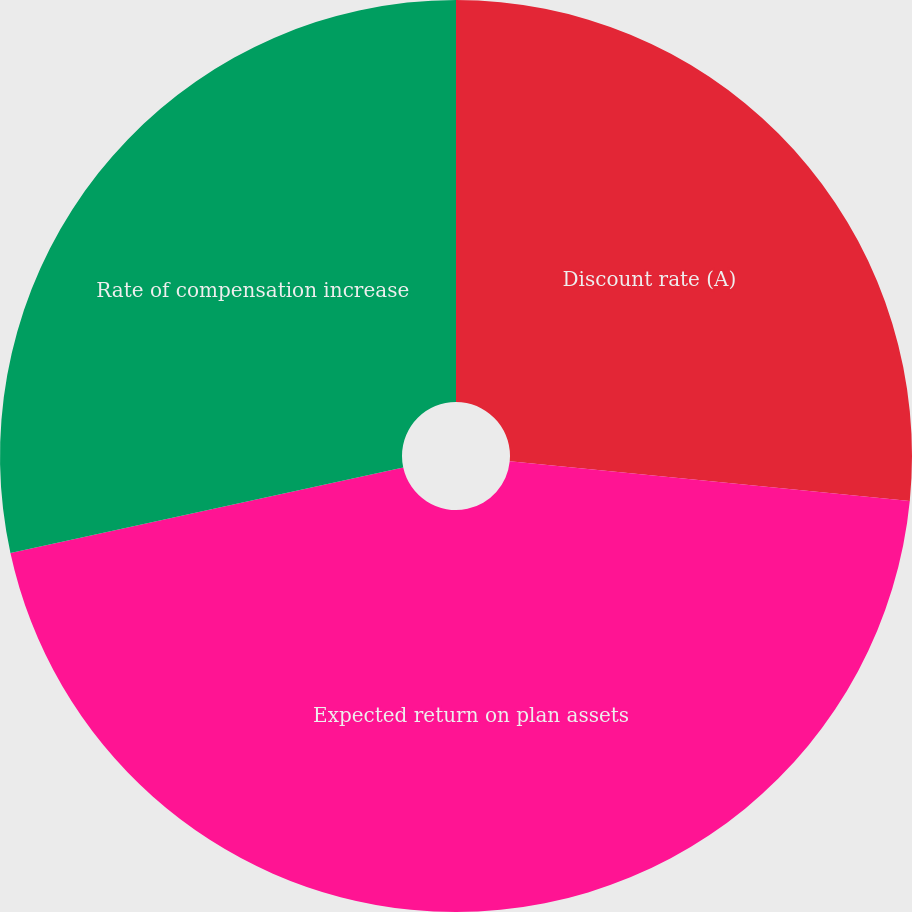Convert chart to OTSL. <chart><loc_0><loc_0><loc_500><loc_500><pie_chart><fcel>Discount rate (A)<fcel>Expected return on plan assets<fcel>Rate of compensation increase<nl><fcel>26.57%<fcel>45.02%<fcel>28.41%<nl></chart> 